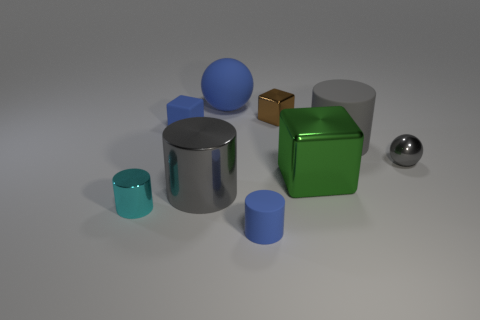What shapes can you identify in the image? There are several distinct shapes present: a large and a small cylinder, a large and a small cube, a sphere, and what appears to be two truncated cones, one large and one small. 